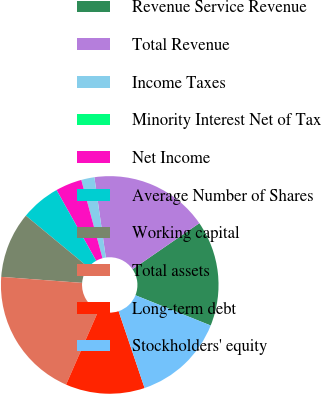Convert chart to OTSL. <chart><loc_0><loc_0><loc_500><loc_500><pie_chart><fcel>Revenue Service Revenue<fcel>Total Revenue<fcel>Income Taxes<fcel>Minority Interest Net of Tax<fcel>Net Income<fcel>Average Number of Shares<fcel>Working capital<fcel>Total assets<fcel>Long-term debt<fcel>Stockholders' equity<nl><fcel>15.68%<fcel>17.64%<fcel>1.96%<fcel>0.0%<fcel>3.92%<fcel>5.88%<fcel>9.8%<fcel>19.6%<fcel>11.76%<fcel>13.72%<nl></chart> 